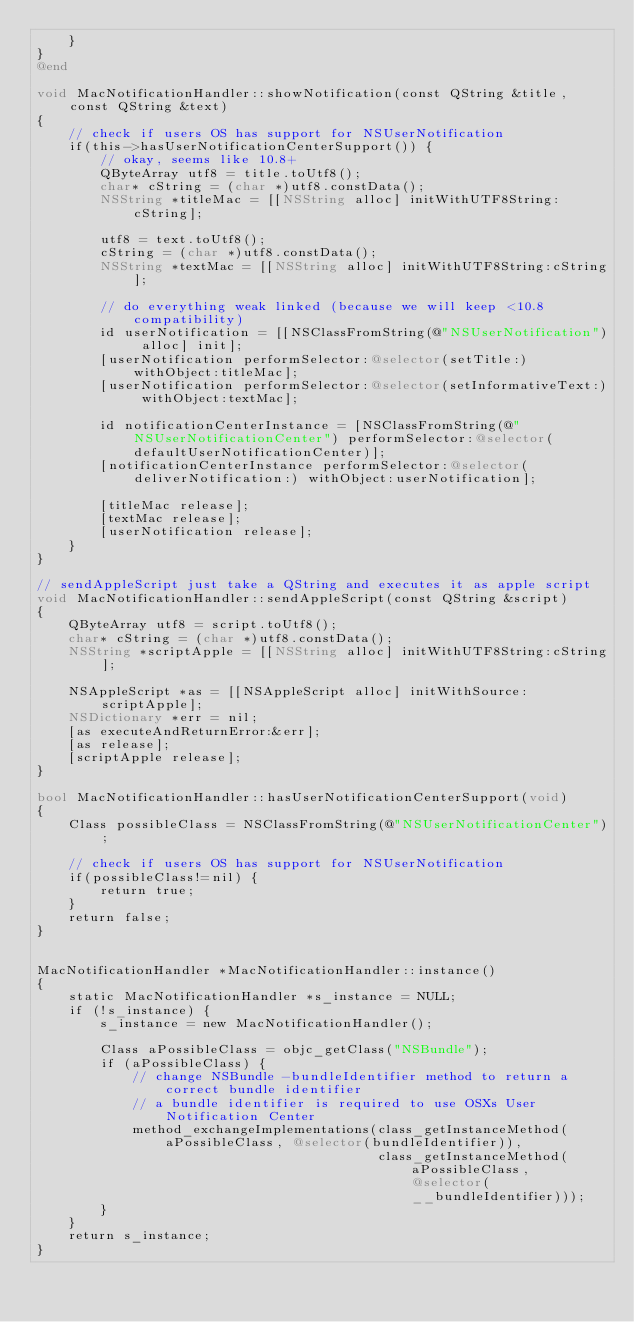Convert code to text. <code><loc_0><loc_0><loc_500><loc_500><_ObjectiveC_>    }
}
@end

void MacNotificationHandler::showNotification(const QString &title, const QString &text)
{
    // check if users OS has support for NSUserNotification
    if(this->hasUserNotificationCenterSupport()) {
        // okay, seems like 10.8+
        QByteArray utf8 = title.toUtf8();
        char* cString = (char *)utf8.constData();
        NSString *titleMac = [[NSString alloc] initWithUTF8String:cString];

        utf8 = text.toUtf8();
        cString = (char *)utf8.constData();
        NSString *textMac = [[NSString alloc] initWithUTF8String:cString];

        // do everything weak linked (because we will keep <10.8 compatibility)
        id userNotification = [[NSClassFromString(@"NSUserNotification") alloc] init];
        [userNotification performSelector:@selector(setTitle:) withObject:titleMac];
        [userNotification performSelector:@selector(setInformativeText:) withObject:textMac];

        id notificationCenterInstance = [NSClassFromString(@"NSUserNotificationCenter") performSelector:@selector(defaultUserNotificationCenter)];
        [notificationCenterInstance performSelector:@selector(deliverNotification:) withObject:userNotification];

        [titleMac release];
        [textMac release];
        [userNotification release];
    }
}

// sendAppleScript just take a QString and executes it as apple script
void MacNotificationHandler::sendAppleScript(const QString &script)
{
    QByteArray utf8 = script.toUtf8();
    char* cString = (char *)utf8.constData();
    NSString *scriptApple = [[NSString alloc] initWithUTF8String:cString];

    NSAppleScript *as = [[NSAppleScript alloc] initWithSource:scriptApple];
    NSDictionary *err = nil;
    [as executeAndReturnError:&err];
    [as release];
    [scriptApple release];
}

bool MacNotificationHandler::hasUserNotificationCenterSupport(void)
{
    Class possibleClass = NSClassFromString(@"NSUserNotificationCenter");

    // check if users OS has support for NSUserNotification
    if(possibleClass!=nil) {
        return true;
    }
    return false;
}


MacNotificationHandler *MacNotificationHandler::instance()
{
    static MacNotificationHandler *s_instance = NULL;
    if (!s_instance) {
        s_instance = new MacNotificationHandler();
        
        Class aPossibleClass = objc_getClass("NSBundle");
        if (aPossibleClass) {
            // change NSBundle -bundleIdentifier method to return a correct bundle identifier
            // a bundle identifier is required to use OSXs User Notification Center
            method_exchangeImplementations(class_getInstanceMethod(aPossibleClass, @selector(bundleIdentifier)),
                                           class_getInstanceMethod(aPossibleClass, @selector(__bundleIdentifier)));
        }
    }
    return s_instance;
}
</code> 